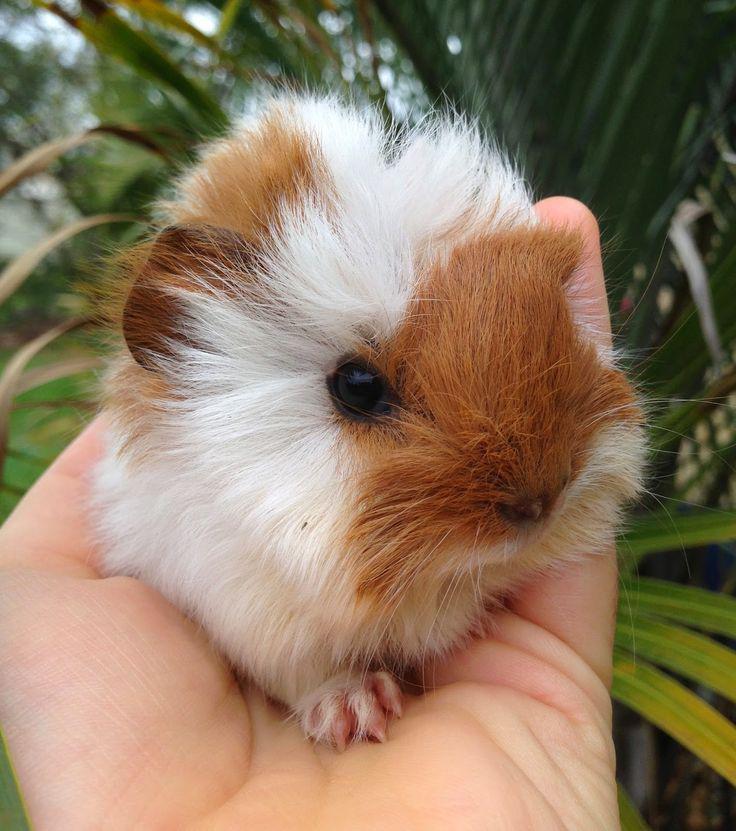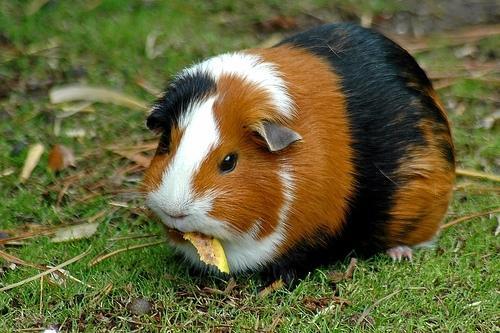The first image is the image on the left, the second image is the image on the right. Assess this claim about the two images: "Three gerbils are in a grassy outdoor area, one alone wearing a costume, while two of different colors are together.". Correct or not? Answer yes or no. No. The first image is the image on the left, the second image is the image on the right. For the images shown, is this caption "An image shows a pet rodent dressed in a uniform vest costume." true? Answer yes or no. No. 